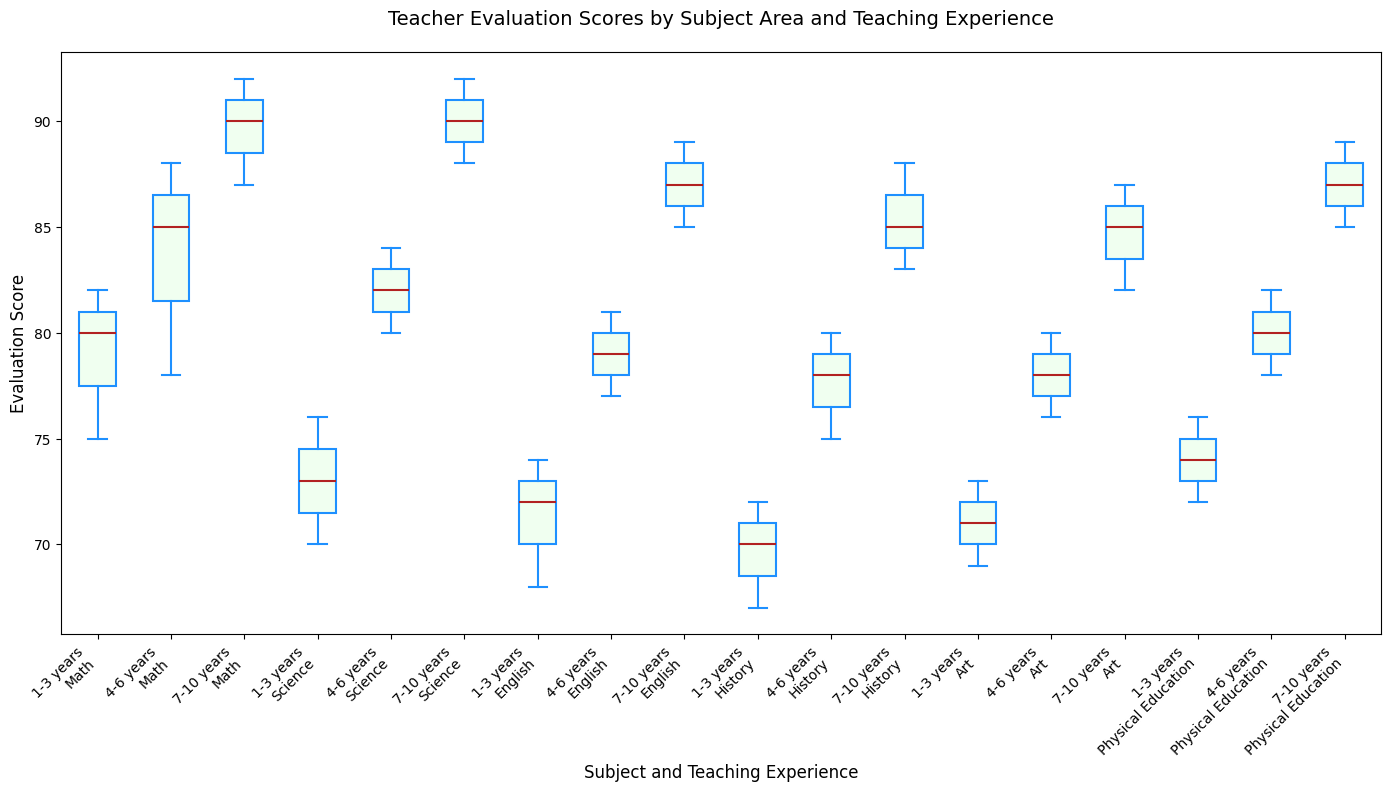How does the median evaluation score for Math teachers compare across different teaching experience levels? To compare the median evaluation scores for Math teachers across different teaching experience levels, you look at the middle line within each box in the box plot for Math. The medians for 1-3 years, 4-6 years, and 7-10 years are around 80, 85, and 90 respectively, showing an increasing trend with more teaching experience.
Answer: The median increases with more experience What is the range of evaluation scores for Science teachers with 1-3 years of experience? The range is calculated by finding the difference between the maximum and minimum values in the box plot for Science teachers with 1-3 years of experience. The whiskers extend roughly from 70 to 76.
Answer: 6 Which subject has the widest range of evaluation scores for teachers with 7-10 years of experience? To find the subject with the widest range, look at the length of the whiskers in the box plot for each subject with 7-10 years of experience. The ranges appear to be (Math: 87-92), (Science: 88-92), (English: 85-89), (History: 83-88), (Art: 82-87), (Physical Education: 85-89). Math clearly has the widest range.
Answer: Math Between Math and Science, which subject has a higher minimum evaluation score for teachers with 4-6 years of experience? Look at the lower whisker end (minimum score) for the box plots of Math and Science teachers with 4-6 years of experience. The minimum for Math is around 78, while for Science it is around 80.
Answer: Science What is the interquartile range (IQR) for Art teachers with 7-10 years of experience? The IQR is the difference between the third quartile (Q3) and the first quartile (Q1). For Art teachers with 7-10 years of experience, Q1 is around 82 and Q3 is around 87, resulting in an IQR of 87-82.
Answer: 5 Is there any subject where the evaluation scores remain constant regardless of the teaching experience level? Check each subject's box plots and see if the medians are similar across all experience levels. Physical Education shows consistent median scores around 75-80 for all experience levels.
Answer: No Which subject has the highest median evaluation score for teachers with 7-10 years of experience? Compare the median lines within the boxes for each subject with 7-10 years of experience. Math shows the highest median, which is around 90.
Answer: Math How do the variability of evaluation scores for History teachers with 1-3 and 4-6 years of experience compare? Check the length of the boxes and the whiskers for History teachers with 1-3 years and 4-6 years of experience. The 1-3 years group has a range of 5, while the 4-6 years group has a range of 5 too, showing similar variability.
Answer: They are similar 